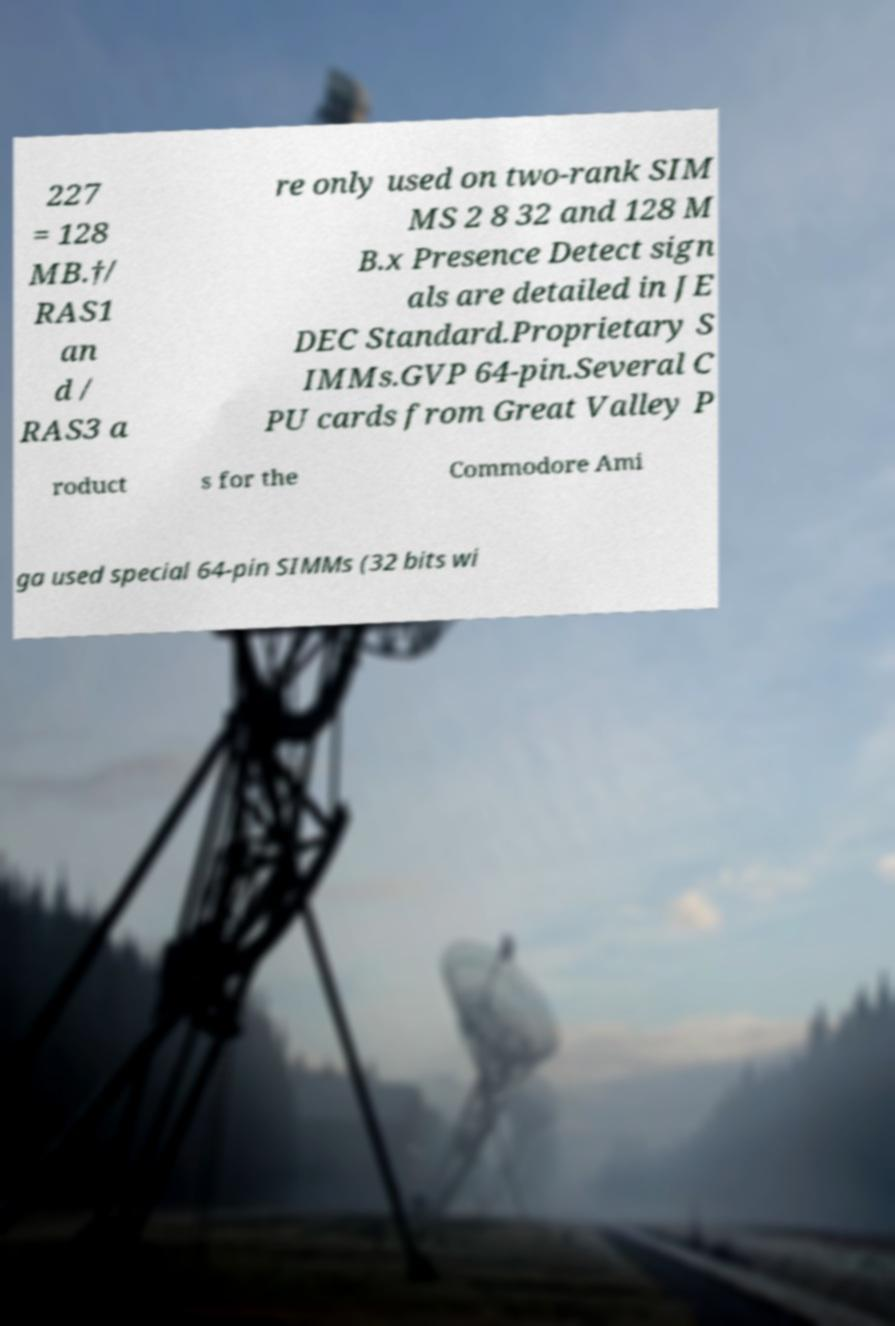Can you read and provide the text displayed in the image?This photo seems to have some interesting text. Can you extract and type it out for me? 227 = 128 MB.†/ RAS1 an d / RAS3 a re only used on two-rank SIM MS 2 8 32 and 128 M B.x Presence Detect sign als are detailed in JE DEC Standard.Proprietary S IMMs.GVP 64-pin.Several C PU cards from Great Valley P roduct s for the Commodore Ami ga used special 64-pin SIMMs (32 bits wi 